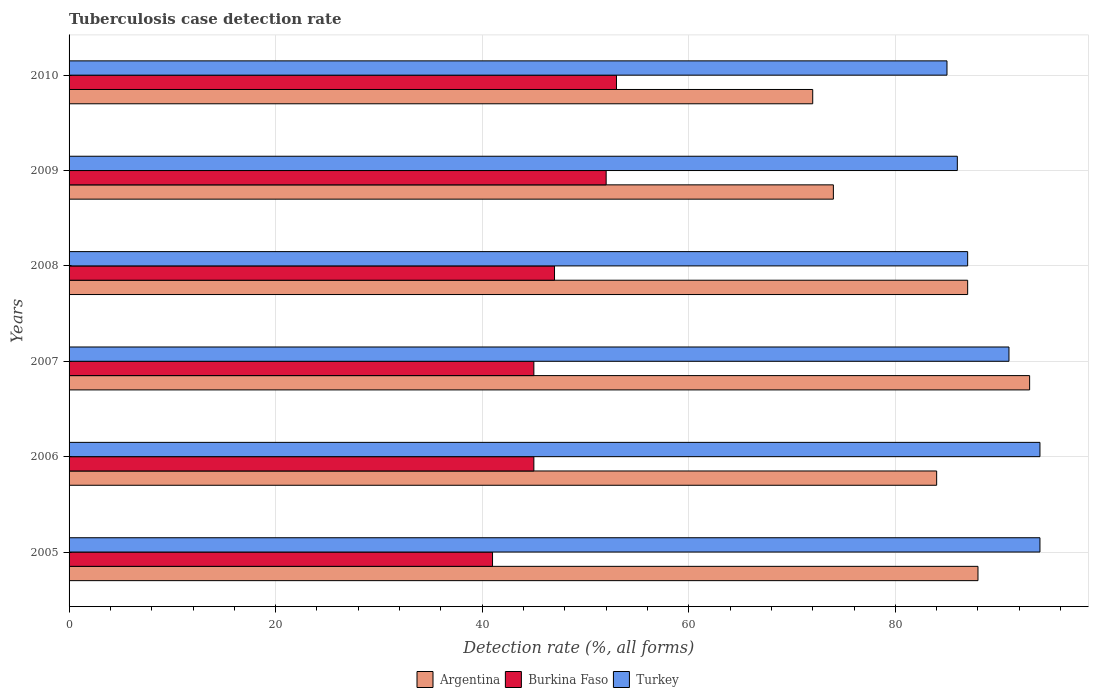How many different coloured bars are there?
Your response must be concise. 3. Are the number of bars on each tick of the Y-axis equal?
Offer a very short reply. Yes. How many bars are there on the 5th tick from the top?
Give a very brief answer. 3. In how many cases, is the number of bars for a given year not equal to the number of legend labels?
Make the answer very short. 0. Across all years, what is the maximum tuberculosis case detection rate in in Turkey?
Provide a short and direct response. 94. Across all years, what is the minimum tuberculosis case detection rate in in Argentina?
Keep it short and to the point. 72. In which year was the tuberculosis case detection rate in in Turkey minimum?
Provide a short and direct response. 2010. What is the total tuberculosis case detection rate in in Burkina Faso in the graph?
Give a very brief answer. 283. What is the difference between the tuberculosis case detection rate in in Argentina in 2005 and the tuberculosis case detection rate in in Turkey in 2009?
Make the answer very short. 2. In the year 2005, what is the difference between the tuberculosis case detection rate in in Turkey and tuberculosis case detection rate in in Argentina?
Keep it short and to the point. 6. In how many years, is the tuberculosis case detection rate in in Burkina Faso greater than 20 %?
Provide a short and direct response. 6. What is the ratio of the tuberculosis case detection rate in in Burkina Faso in 2005 to that in 2008?
Make the answer very short. 0.87. What is the difference between the highest and the second highest tuberculosis case detection rate in in Turkey?
Offer a very short reply. 0. In how many years, is the tuberculosis case detection rate in in Argentina greater than the average tuberculosis case detection rate in in Argentina taken over all years?
Offer a terse response. 4. What does the 2nd bar from the top in 2009 represents?
Make the answer very short. Burkina Faso. Is it the case that in every year, the sum of the tuberculosis case detection rate in in Burkina Faso and tuberculosis case detection rate in in Turkey is greater than the tuberculosis case detection rate in in Argentina?
Provide a succinct answer. Yes. What is the difference between two consecutive major ticks on the X-axis?
Ensure brevity in your answer.  20. Are the values on the major ticks of X-axis written in scientific E-notation?
Provide a short and direct response. No. Does the graph contain any zero values?
Ensure brevity in your answer.  No. How many legend labels are there?
Provide a succinct answer. 3. How are the legend labels stacked?
Offer a terse response. Horizontal. What is the title of the graph?
Your answer should be compact. Tuberculosis case detection rate. What is the label or title of the X-axis?
Offer a terse response. Detection rate (%, all forms). What is the label or title of the Y-axis?
Provide a short and direct response. Years. What is the Detection rate (%, all forms) in Turkey in 2005?
Your response must be concise. 94. What is the Detection rate (%, all forms) of Argentina in 2006?
Offer a very short reply. 84. What is the Detection rate (%, all forms) in Turkey in 2006?
Offer a terse response. 94. What is the Detection rate (%, all forms) of Argentina in 2007?
Your response must be concise. 93. What is the Detection rate (%, all forms) of Burkina Faso in 2007?
Your response must be concise. 45. What is the Detection rate (%, all forms) in Turkey in 2007?
Your answer should be compact. 91. What is the Detection rate (%, all forms) of Turkey in 2008?
Offer a very short reply. 87. What is the Detection rate (%, all forms) in Burkina Faso in 2009?
Ensure brevity in your answer.  52. What is the Detection rate (%, all forms) of Burkina Faso in 2010?
Keep it short and to the point. 53. What is the Detection rate (%, all forms) in Turkey in 2010?
Ensure brevity in your answer.  85. Across all years, what is the maximum Detection rate (%, all forms) in Argentina?
Your answer should be compact. 93. Across all years, what is the maximum Detection rate (%, all forms) of Burkina Faso?
Offer a very short reply. 53. Across all years, what is the maximum Detection rate (%, all forms) of Turkey?
Provide a short and direct response. 94. Across all years, what is the minimum Detection rate (%, all forms) in Burkina Faso?
Your response must be concise. 41. What is the total Detection rate (%, all forms) of Argentina in the graph?
Provide a short and direct response. 498. What is the total Detection rate (%, all forms) of Burkina Faso in the graph?
Make the answer very short. 283. What is the total Detection rate (%, all forms) of Turkey in the graph?
Make the answer very short. 537. What is the difference between the Detection rate (%, all forms) in Argentina in 2005 and that in 2006?
Your answer should be compact. 4. What is the difference between the Detection rate (%, all forms) of Turkey in 2005 and that in 2007?
Keep it short and to the point. 3. What is the difference between the Detection rate (%, all forms) in Argentina in 2005 and that in 2008?
Your response must be concise. 1. What is the difference between the Detection rate (%, all forms) of Burkina Faso in 2005 and that in 2008?
Offer a terse response. -6. What is the difference between the Detection rate (%, all forms) of Turkey in 2005 and that in 2008?
Provide a succinct answer. 7. What is the difference between the Detection rate (%, all forms) of Turkey in 2005 and that in 2009?
Give a very brief answer. 8. What is the difference between the Detection rate (%, all forms) of Argentina in 2005 and that in 2010?
Provide a succinct answer. 16. What is the difference between the Detection rate (%, all forms) of Argentina in 2006 and that in 2007?
Your answer should be very brief. -9. What is the difference between the Detection rate (%, all forms) of Burkina Faso in 2006 and that in 2009?
Keep it short and to the point. -7. What is the difference between the Detection rate (%, all forms) in Burkina Faso in 2007 and that in 2008?
Offer a terse response. -2. What is the difference between the Detection rate (%, all forms) of Turkey in 2007 and that in 2008?
Keep it short and to the point. 4. What is the difference between the Detection rate (%, all forms) of Argentina in 2007 and that in 2009?
Provide a short and direct response. 19. What is the difference between the Detection rate (%, all forms) in Turkey in 2007 and that in 2009?
Your answer should be compact. 5. What is the difference between the Detection rate (%, all forms) in Burkina Faso in 2007 and that in 2010?
Offer a terse response. -8. What is the difference between the Detection rate (%, all forms) of Argentina in 2008 and that in 2009?
Your response must be concise. 13. What is the difference between the Detection rate (%, all forms) of Burkina Faso in 2008 and that in 2009?
Provide a short and direct response. -5. What is the difference between the Detection rate (%, all forms) of Burkina Faso in 2008 and that in 2010?
Offer a terse response. -6. What is the difference between the Detection rate (%, all forms) of Argentina in 2005 and the Detection rate (%, all forms) of Burkina Faso in 2006?
Provide a short and direct response. 43. What is the difference between the Detection rate (%, all forms) of Burkina Faso in 2005 and the Detection rate (%, all forms) of Turkey in 2006?
Your response must be concise. -53. What is the difference between the Detection rate (%, all forms) in Burkina Faso in 2005 and the Detection rate (%, all forms) in Turkey in 2007?
Keep it short and to the point. -50. What is the difference between the Detection rate (%, all forms) of Argentina in 2005 and the Detection rate (%, all forms) of Burkina Faso in 2008?
Your response must be concise. 41. What is the difference between the Detection rate (%, all forms) in Burkina Faso in 2005 and the Detection rate (%, all forms) in Turkey in 2008?
Keep it short and to the point. -46. What is the difference between the Detection rate (%, all forms) in Burkina Faso in 2005 and the Detection rate (%, all forms) in Turkey in 2009?
Give a very brief answer. -45. What is the difference between the Detection rate (%, all forms) of Burkina Faso in 2005 and the Detection rate (%, all forms) of Turkey in 2010?
Your answer should be very brief. -44. What is the difference between the Detection rate (%, all forms) of Argentina in 2006 and the Detection rate (%, all forms) of Burkina Faso in 2007?
Give a very brief answer. 39. What is the difference between the Detection rate (%, all forms) in Argentina in 2006 and the Detection rate (%, all forms) in Turkey in 2007?
Ensure brevity in your answer.  -7. What is the difference between the Detection rate (%, all forms) in Burkina Faso in 2006 and the Detection rate (%, all forms) in Turkey in 2007?
Provide a short and direct response. -46. What is the difference between the Detection rate (%, all forms) in Argentina in 2006 and the Detection rate (%, all forms) in Burkina Faso in 2008?
Offer a terse response. 37. What is the difference between the Detection rate (%, all forms) in Argentina in 2006 and the Detection rate (%, all forms) in Turkey in 2008?
Keep it short and to the point. -3. What is the difference between the Detection rate (%, all forms) of Burkina Faso in 2006 and the Detection rate (%, all forms) of Turkey in 2008?
Your answer should be compact. -42. What is the difference between the Detection rate (%, all forms) of Argentina in 2006 and the Detection rate (%, all forms) of Burkina Faso in 2009?
Offer a very short reply. 32. What is the difference between the Detection rate (%, all forms) in Argentina in 2006 and the Detection rate (%, all forms) in Turkey in 2009?
Provide a short and direct response. -2. What is the difference between the Detection rate (%, all forms) of Burkina Faso in 2006 and the Detection rate (%, all forms) of Turkey in 2009?
Provide a short and direct response. -41. What is the difference between the Detection rate (%, all forms) in Burkina Faso in 2006 and the Detection rate (%, all forms) in Turkey in 2010?
Give a very brief answer. -40. What is the difference between the Detection rate (%, all forms) of Argentina in 2007 and the Detection rate (%, all forms) of Burkina Faso in 2008?
Make the answer very short. 46. What is the difference between the Detection rate (%, all forms) of Burkina Faso in 2007 and the Detection rate (%, all forms) of Turkey in 2008?
Keep it short and to the point. -42. What is the difference between the Detection rate (%, all forms) of Argentina in 2007 and the Detection rate (%, all forms) of Burkina Faso in 2009?
Provide a short and direct response. 41. What is the difference between the Detection rate (%, all forms) in Burkina Faso in 2007 and the Detection rate (%, all forms) in Turkey in 2009?
Your answer should be compact. -41. What is the difference between the Detection rate (%, all forms) in Argentina in 2007 and the Detection rate (%, all forms) in Burkina Faso in 2010?
Give a very brief answer. 40. What is the difference between the Detection rate (%, all forms) in Argentina in 2007 and the Detection rate (%, all forms) in Turkey in 2010?
Provide a short and direct response. 8. What is the difference between the Detection rate (%, all forms) in Burkina Faso in 2008 and the Detection rate (%, all forms) in Turkey in 2009?
Make the answer very short. -39. What is the difference between the Detection rate (%, all forms) in Argentina in 2008 and the Detection rate (%, all forms) in Turkey in 2010?
Provide a short and direct response. 2. What is the difference between the Detection rate (%, all forms) of Burkina Faso in 2008 and the Detection rate (%, all forms) of Turkey in 2010?
Provide a short and direct response. -38. What is the difference between the Detection rate (%, all forms) of Argentina in 2009 and the Detection rate (%, all forms) of Burkina Faso in 2010?
Your answer should be compact. 21. What is the difference between the Detection rate (%, all forms) in Argentina in 2009 and the Detection rate (%, all forms) in Turkey in 2010?
Your response must be concise. -11. What is the difference between the Detection rate (%, all forms) in Burkina Faso in 2009 and the Detection rate (%, all forms) in Turkey in 2010?
Keep it short and to the point. -33. What is the average Detection rate (%, all forms) of Burkina Faso per year?
Give a very brief answer. 47.17. What is the average Detection rate (%, all forms) of Turkey per year?
Your answer should be compact. 89.5. In the year 2005, what is the difference between the Detection rate (%, all forms) in Burkina Faso and Detection rate (%, all forms) in Turkey?
Your answer should be very brief. -53. In the year 2006, what is the difference between the Detection rate (%, all forms) of Burkina Faso and Detection rate (%, all forms) of Turkey?
Provide a short and direct response. -49. In the year 2007, what is the difference between the Detection rate (%, all forms) of Burkina Faso and Detection rate (%, all forms) of Turkey?
Offer a terse response. -46. In the year 2008, what is the difference between the Detection rate (%, all forms) of Argentina and Detection rate (%, all forms) of Turkey?
Give a very brief answer. 0. In the year 2008, what is the difference between the Detection rate (%, all forms) of Burkina Faso and Detection rate (%, all forms) of Turkey?
Ensure brevity in your answer.  -40. In the year 2009, what is the difference between the Detection rate (%, all forms) in Argentina and Detection rate (%, all forms) in Burkina Faso?
Make the answer very short. 22. In the year 2009, what is the difference between the Detection rate (%, all forms) in Argentina and Detection rate (%, all forms) in Turkey?
Your response must be concise. -12. In the year 2009, what is the difference between the Detection rate (%, all forms) in Burkina Faso and Detection rate (%, all forms) in Turkey?
Keep it short and to the point. -34. In the year 2010, what is the difference between the Detection rate (%, all forms) in Argentina and Detection rate (%, all forms) in Burkina Faso?
Give a very brief answer. 19. In the year 2010, what is the difference between the Detection rate (%, all forms) of Argentina and Detection rate (%, all forms) of Turkey?
Offer a terse response. -13. In the year 2010, what is the difference between the Detection rate (%, all forms) of Burkina Faso and Detection rate (%, all forms) of Turkey?
Give a very brief answer. -32. What is the ratio of the Detection rate (%, all forms) of Argentina in 2005 to that in 2006?
Your response must be concise. 1.05. What is the ratio of the Detection rate (%, all forms) in Burkina Faso in 2005 to that in 2006?
Your response must be concise. 0.91. What is the ratio of the Detection rate (%, all forms) in Turkey in 2005 to that in 2006?
Keep it short and to the point. 1. What is the ratio of the Detection rate (%, all forms) of Argentina in 2005 to that in 2007?
Offer a very short reply. 0.95. What is the ratio of the Detection rate (%, all forms) in Burkina Faso in 2005 to that in 2007?
Make the answer very short. 0.91. What is the ratio of the Detection rate (%, all forms) in Turkey in 2005 to that in 2007?
Provide a succinct answer. 1.03. What is the ratio of the Detection rate (%, all forms) in Argentina in 2005 to that in 2008?
Your answer should be very brief. 1.01. What is the ratio of the Detection rate (%, all forms) in Burkina Faso in 2005 to that in 2008?
Provide a succinct answer. 0.87. What is the ratio of the Detection rate (%, all forms) of Turkey in 2005 to that in 2008?
Keep it short and to the point. 1.08. What is the ratio of the Detection rate (%, all forms) in Argentina in 2005 to that in 2009?
Keep it short and to the point. 1.19. What is the ratio of the Detection rate (%, all forms) of Burkina Faso in 2005 to that in 2009?
Ensure brevity in your answer.  0.79. What is the ratio of the Detection rate (%, all forms) in Turkey in 2005 to that in 2009?
Offer a terse response. 1.09. What is the ratio of the Detection rate (%, all forms) of Argentina in 2005 to that in 2010?
Give a very brief answer. 1.22. What is the ratio of the Detection rate (%, all forms) of Burkina Faso in 2005 to that in 2010?
Ensure brevity in your answer.  0.77. What is the ratio of the Detection rate (%, all forms) in Turkey in 2005 to that in 2010?
Keep it short and to the point. 1.11. What is the ratio of the Detection rate (%, all forms) of Argentina in 2006 to that in 2007?
Ensure brevity in your answer.  0.9. What is the ratio of the Detection rate (%, all forms) of Burkina Faso in 2006 to that in 2007?
Give a very brief answer. 1. What is the ratio of the Detection rate (%, all forms) in Turkey in 2006 to that in 2007?
Ensure brevity in your answer.  1.03. What is the ratio of the Detection rate (%, all forms) in Argentina in 2006 to that in 2008?
Keep it short and to the point. 0.97. What is the ratio of the Detection rate (%, all forms) in Burkina Faso in 2006 to that in 2008?
Provide a short and direct response. 0.96. What is the ratio of the Detection rate (%, all forms) of Turkey in 2006 to that in 2008?
Provide a short and direct response. 1.08. What is the ratio of the Detection rate (%, all forms) of Argentina in 2006 to that in 2009?
Give a very brief answer. 1.14. What is the ratio of the Detection rate (%, all forms) of Burkina Faso in 2006 to that in 2009?
Your answer should be compact. 0.87. What is the ratio of the Detection rate (%, all forms) in Turkey in 2006 to that in 2009?
Your answer should be very brief. 1.09. What is the ratio of the Detection rate (%, all forms) in Argentina in 2006 to that in 2010?
Your response must be concise. 1.17. What is the ratio of the Detection rate (%, all forms) of Burkina Faso in 2006 to that in 2010?
Give a very brief answer. 0.85. What is the ratio of the Detection rate (%, all forms) of Turkey in 2006 to that in 2010?
Keep it short and to the point. 1.11. What is the ratio of the Detection rate (%, all forms) of Argentina in 2007 to that in 2008?
Offer a very short reply. 1.07. What is the ratio of the Detection rate (%, all forms) in Burkina Faso in 2007 to that in 2008?
Offer a terse response. 0.96. What is the ratio of the Detection rate (%, all forms) in Turkey in 2007 to that in 2008?
Provide a succinct answer. 1.05. What is the ratio of the Detection rate (%, all forms) in Argentina in 2007 to that in 2009?
Give a very brief answer. 1.26. What is the ratio of the Detection rate (%, all forms) of Burkina Faso in 2007 to that in 2009?
Offer a very short reply. 0.87. What is the ratio of the Detection rate (%, all forms) of Turkey in 2007 to that in 2009?
Make the answer very short. 1.06. What is the ratio of the Detection rate (%, all forms) of Argentina in 2007 to that in 2010?
Your answer should be very brief. 1.29. What is the ratio of the Detection rate (%, all forms) of Burkina Faso in 2007 to that in 2010?
Your answer should be compact. 0.85. What is the ratio of the Detection rate (%, all forms) in Turkey in 2007 to that in 2010?
Offer a very short reply. 1.07. What is the ratio of the Detection rate (%, all forms) in Argentina in 2008 to that in 2009?
Provide a short and direct response. 1.18. What is the ratio of the Detection rate (%, all forms) of Burkina Faso in 2008 to that in 2009?
Offer a very short reply. 0.9. What is the ratio of the Detection rate (%, all forms) of Turkey in 2008 to that in 2009?
Your response must be concise. 1.01. What is the ratio of the Detection rate (%, all forms) of Argentina in 2008 to that in 2010?
Your answer should be very brief. 1.21. What is the ratio of the Detection rate (%, all forms) in Burkina Faso in 2008 to that in 2010?
Your response must be concise. 0.89. What is the ratio of the Detection rate (%, all forms) of Turkey in 2008 to that in 2010?
Offer a terse response. 1.02. What is the ratio of the Detection rate (%, all forms) in Argentina in 2009 to that in 2010?
Offer a terse response. 1.03. What is the ratio of the Detection rate (%, all forms) in Burkina Faso in 2009 to that in 2010?
Keep it short and to the point. 0.98. What is the ratio of the Detection rate (%, all forms) in Turkey in 2009 to that in 2010?
Your response must be concise. 1.01. What is the difference between the highest and the second highest Detection rate (%, all forms) of Burkina Faso?
Offer a very short reply. 1. What is the difference between the highest and the second highest Detection rate (%, all forms) in Turkey?
Offer a terse response. 0. What is the difference between the highest and the lowest Detection rate (%, all forms) in Argentina?
Give a very brief answer. 21. What is the difference between the highest and the lowest Detection rate (%, all forms) of Burkina Faso?
Offer a very short reply. 12. 